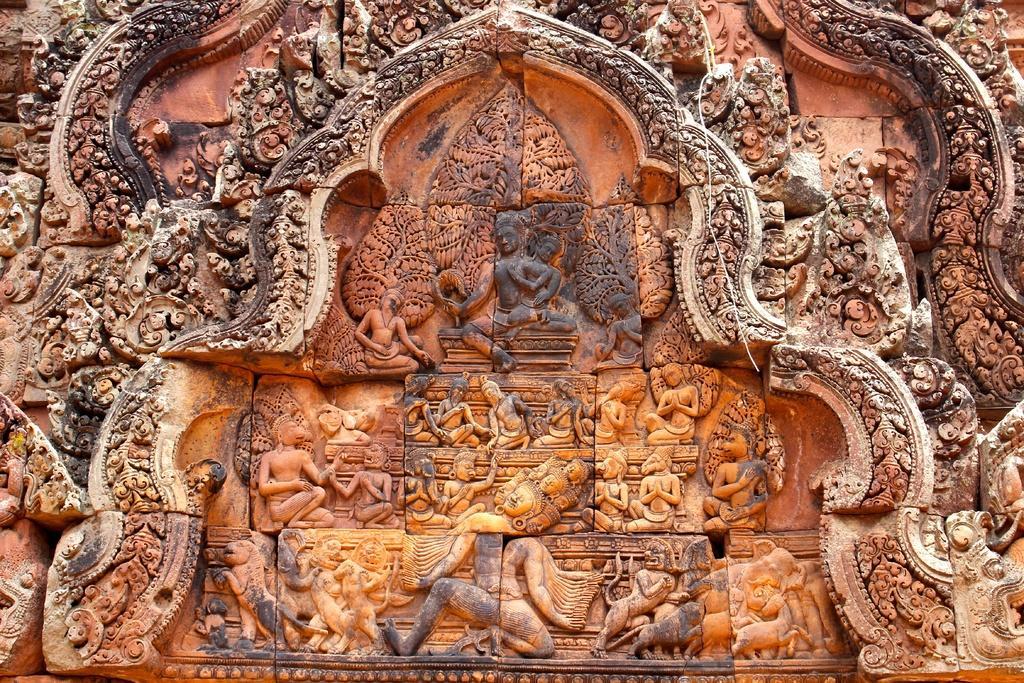Can you describe this image briefly? In this image on a wall there are sculptures and different designs. 